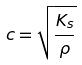<formula> <loc_0><loc_0><loc_500><loc_500>c = \sqrt { \frac { K _ { s } } { \rho } }</formula> 